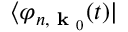Convert formula to latex. <formula><loc_0><loc_0><loc_500><loc_500>\langle \varphi _ { n , k _ { 0 } } ( t ) |</formula> 